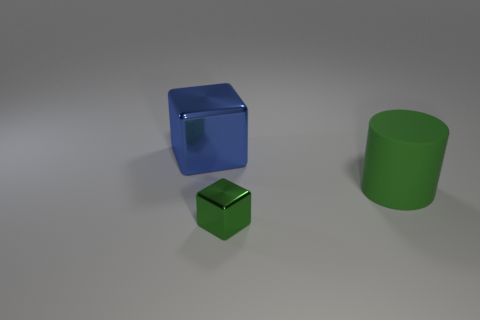Subtract 0 cyan cylinders. How many objects are left? 3 Subtract all cylinders. How many objects are left? 2 Subtract all brown cylinders. Subtract all blue blocks. How many cylinders are left? 1 Subtract all blue cubes. How many gray cylinders are left? 0 Subtract all tiny blue rubber objects. Subtract all green metallic things. How many objects are left? 2 Add 1 big cylinders. How many big cylinders are left? 2 Add 2 tiny green shiny objects. How many tiny green shiny objects exist? 3 Add 1 big green cylinders. How many objects exist? 4 Subtract all green cubes. How many cubes are left? 1 